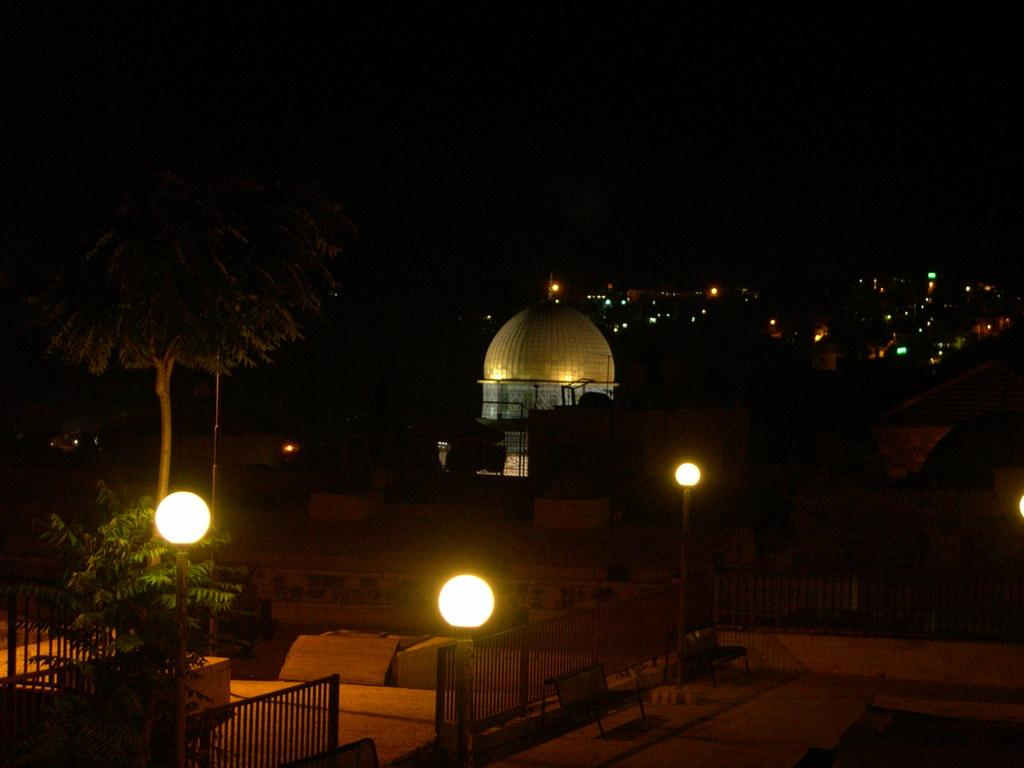What type of structures can be seen in the image? There are buildings in the image. What can be seen illuminating the scene in the image? There are lights visible in the image. What type of natural vegetation is present in the image? There are trees in the image. What type of barrier is present in the image? There is a fence in the image. How would you describe the overall lighting condition in the image? The background of the image is dark. What type of lunch is being served in the image? There is no lunch present in the image. How old is the daughter in the image? There is no daughter present in the image. How many clocks can be seen in the image? There are no clocks present in the image. 